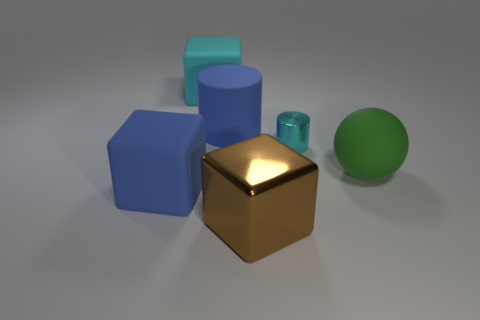Is the lighting in this scene artificial or natural, and how can you tell? The lighting in this scene appears artificial due to the uniform shadows and soft light sources, which suggests it's a computer-generated image. Natural light often varies in intensity and color, and the shadows cast would typically be less uniform. 